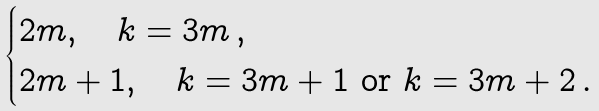Convert formula to latex. <formula><loc_0><loc_0><loc_500><loc_500>\begin{cases} 2 m , \quad k = 3 m \, , \\ 2 m + 1 , \quad k = 3 m + 1 \text { or } k = 3 m + 2 \, . \end{cases}</formula> 